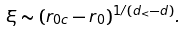<formula> <loc_0><loc_0><loc_500><loc_500>\xi \sim ( r _ { 0 c } - r _ { 0 } ) ^ { 1 / ( d _ { < } - d ) } .</formula> 